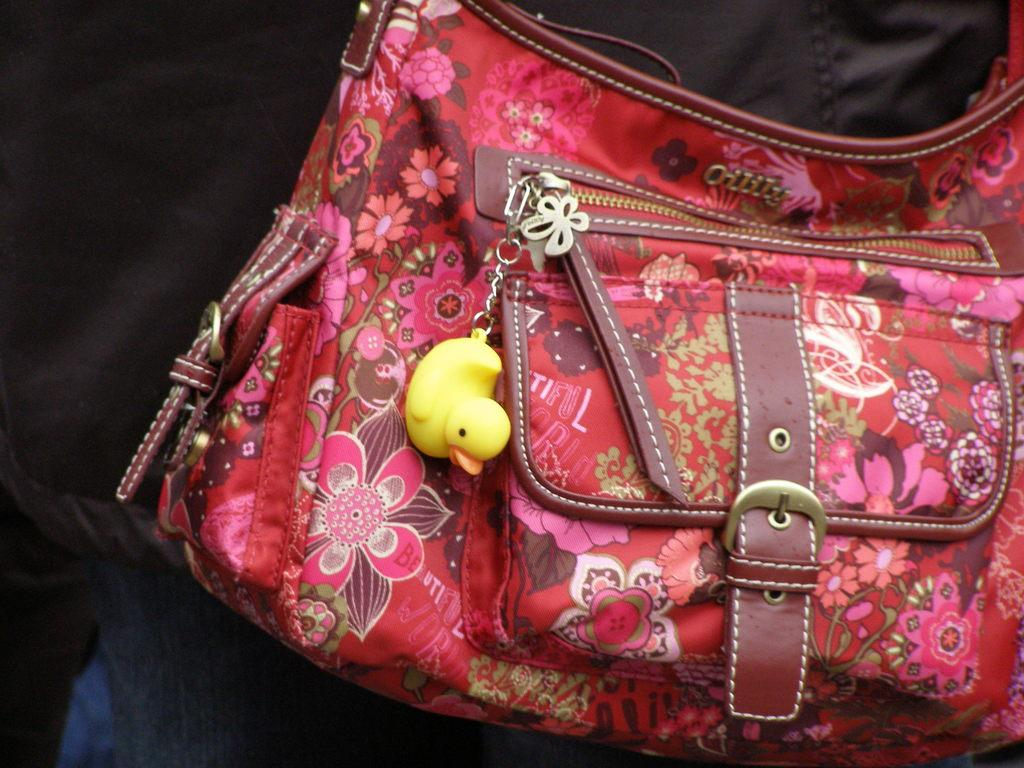What is present in the image? There is a bag in the image. What is attached to the bag? There is a duck keychain on the bag. Is there a veil covering the duck keychain in the image? No, there is no veil present in the image. 